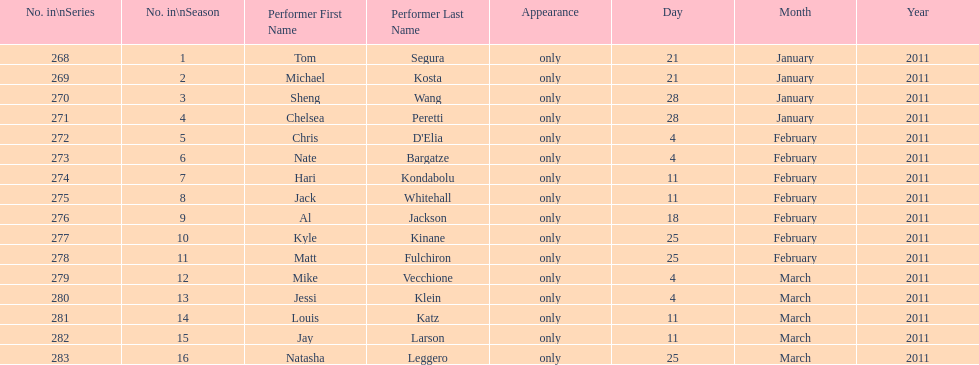How many performers appeared on the air date 21 january 2011? 2. 